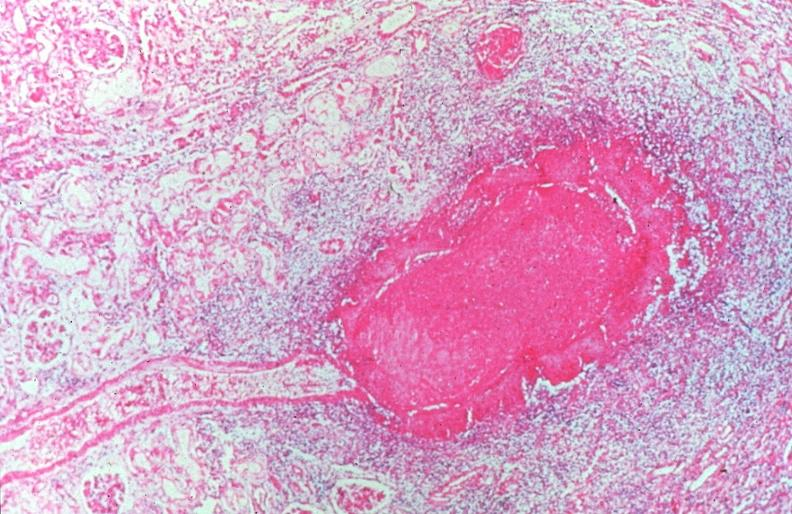what does this image show?
Answer the question using a single word or phrase. Vasculitis 